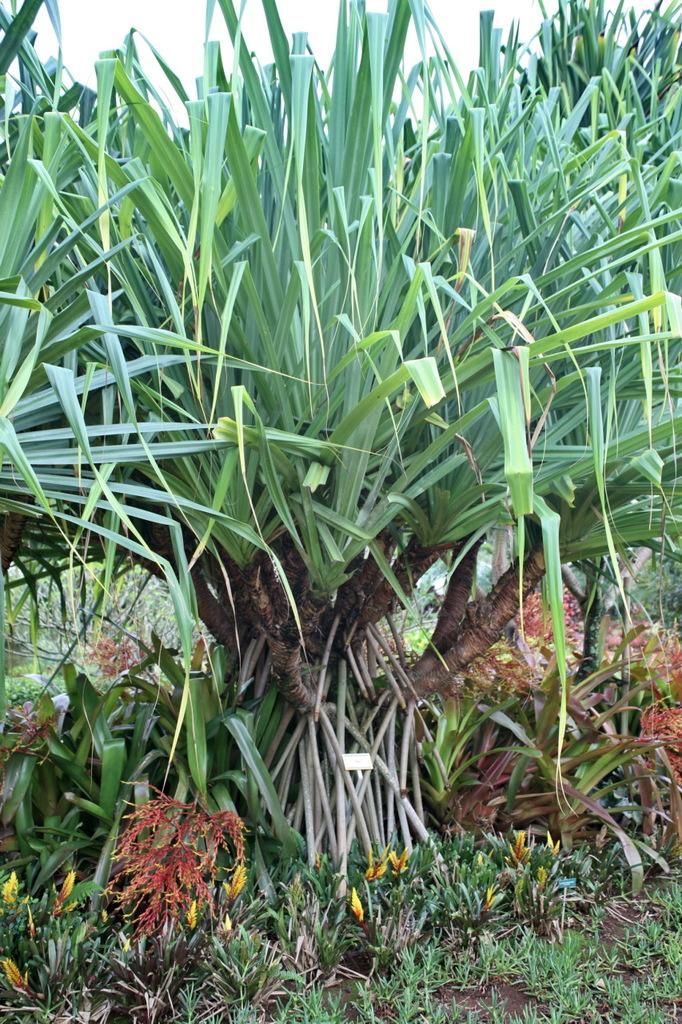What celestial bodies can be seen in the image? There are planets visible in the image. What is the condition of the sky in the image? The sky appears to be cloudy in the image. What scent can be detected from the hen in the image? There is no hen present in the image, so it is not possible to determine any scent. 